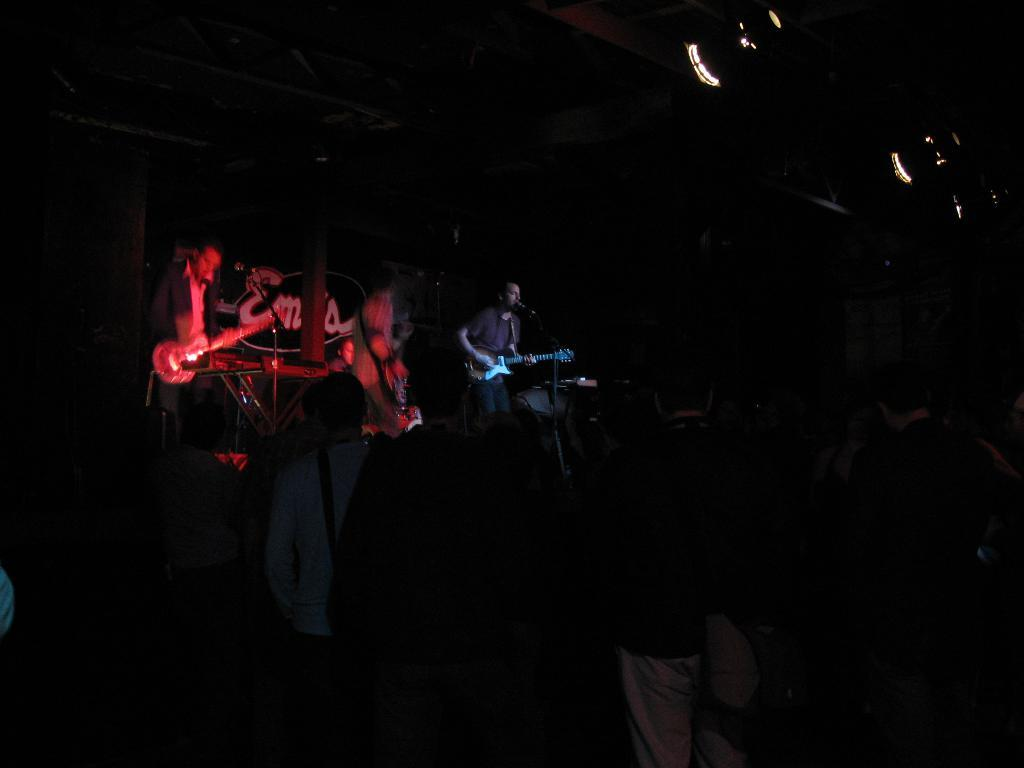What is happening in the image? There is a group of people standing in the image. What are some of the people in the image doing? There are people holding musical instruments in the image. Can you describe the setup of the people with musical instruments? These people with musical instruments are standing in front of a microphone. What type of crime is being committed in the image? There is no crime being committed in the image; it features a group of people standing with musical instruments and a microphone. What is the size of the orange in the image? There is no orange present in the image. 